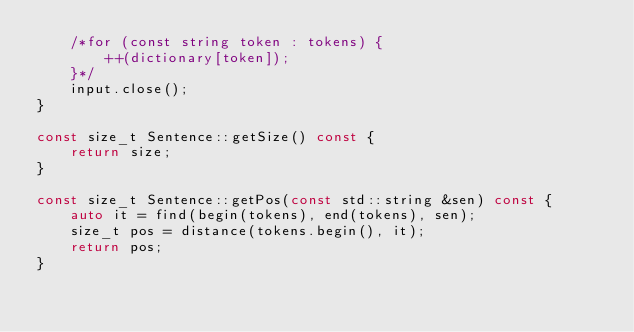Convert code to text. <code><loc_0><loc_0><loc_500><loc_500><_C++_>    /*for (const string token : tokens) {
        ++(dictionary[token]);
    }*/
    input.close();
}

const size_t Sentence::getSize() const {
    return size;
}

const size_t Sentence::getPos(const std::string &sen) const {
    auto it = find(begin(tokens), end(tokens), sen);
    size_t pos = distance(tokens.begin(), it);
    return pos;
}


</code> 